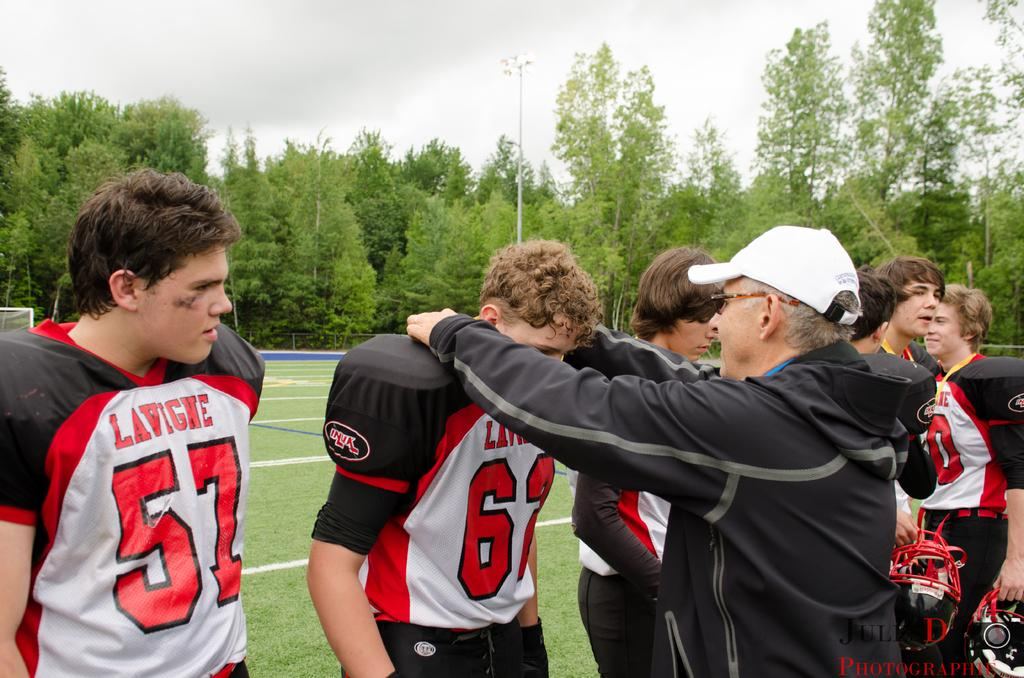<image>
Share a concise interpretation of the image provided. Player 57 stands beside his team mates and an older man talking to them. 